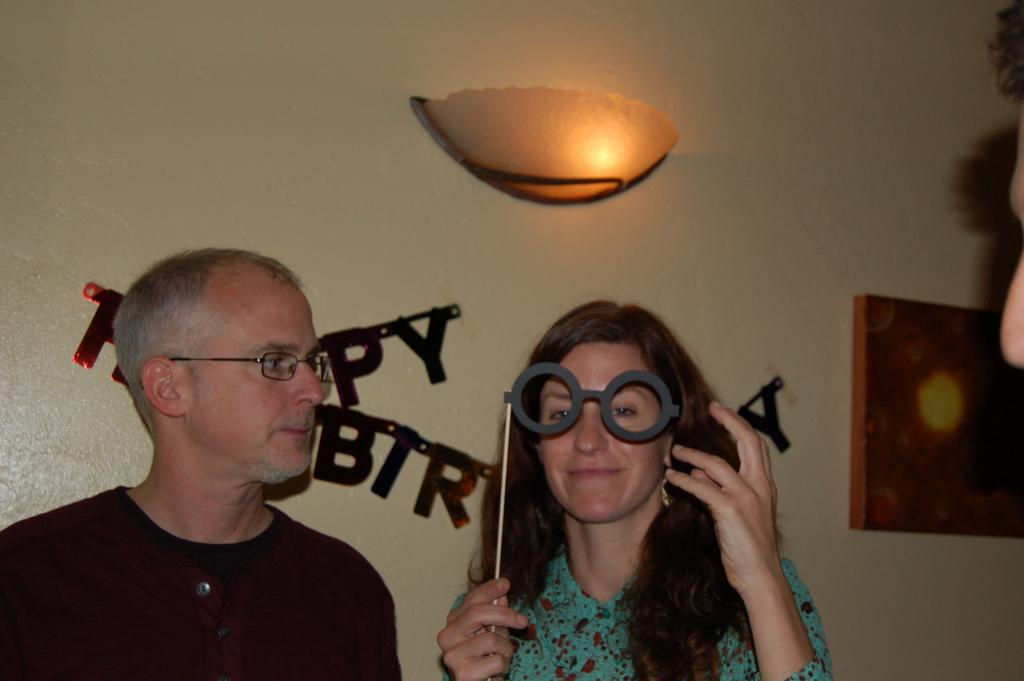How many people are in the image? There are people in the image, but the exact number is not specified. What is one person holding in the image? One person is holding a mask in the image. What can be seen in the background of the image? There is light, letters on a wall, and a box in the background of some kind in the background of the image. What type of rock is being used as a paperweight on the desk in the image? There is no desk or rock present in the image. Can you tell me how many beetles are crawling on the person holding the mask? There are no beetles visible in the image; only people and a mask are present. 